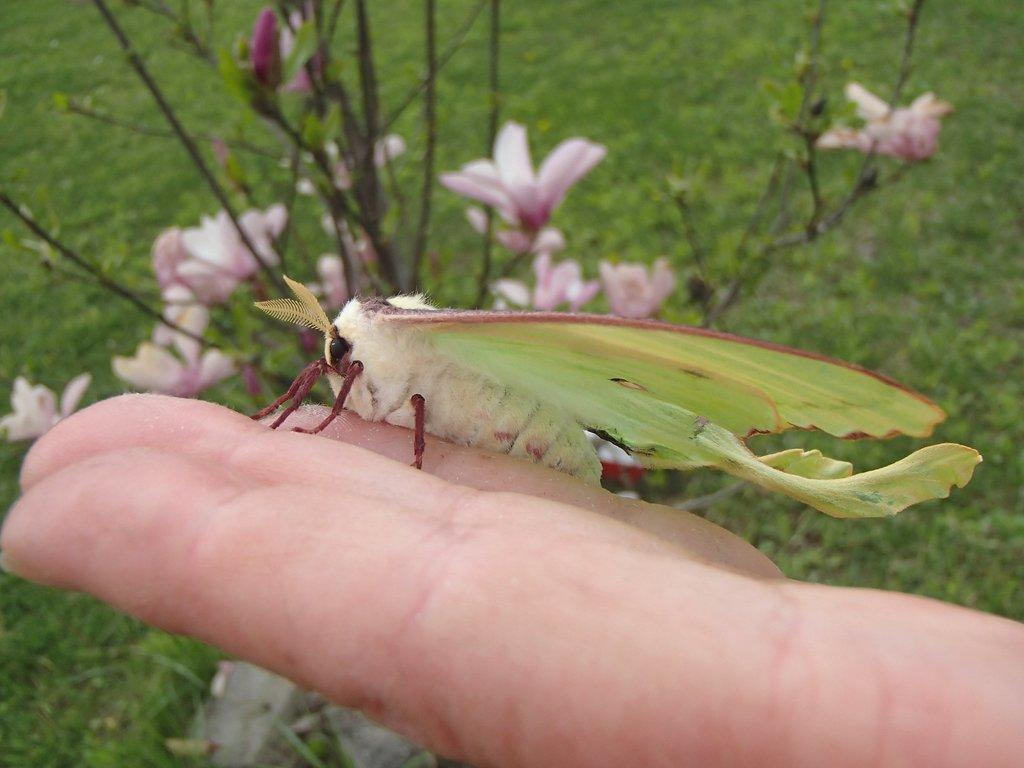What is the person's hand holding in the image? The person's hand is holding an insect in the image. What can be seen in the background of the image? There are flowers and grass in the background of the image. What is the person's feeling towards the insect in the image? The image does not provide information about the person's feelings towards the insect. 